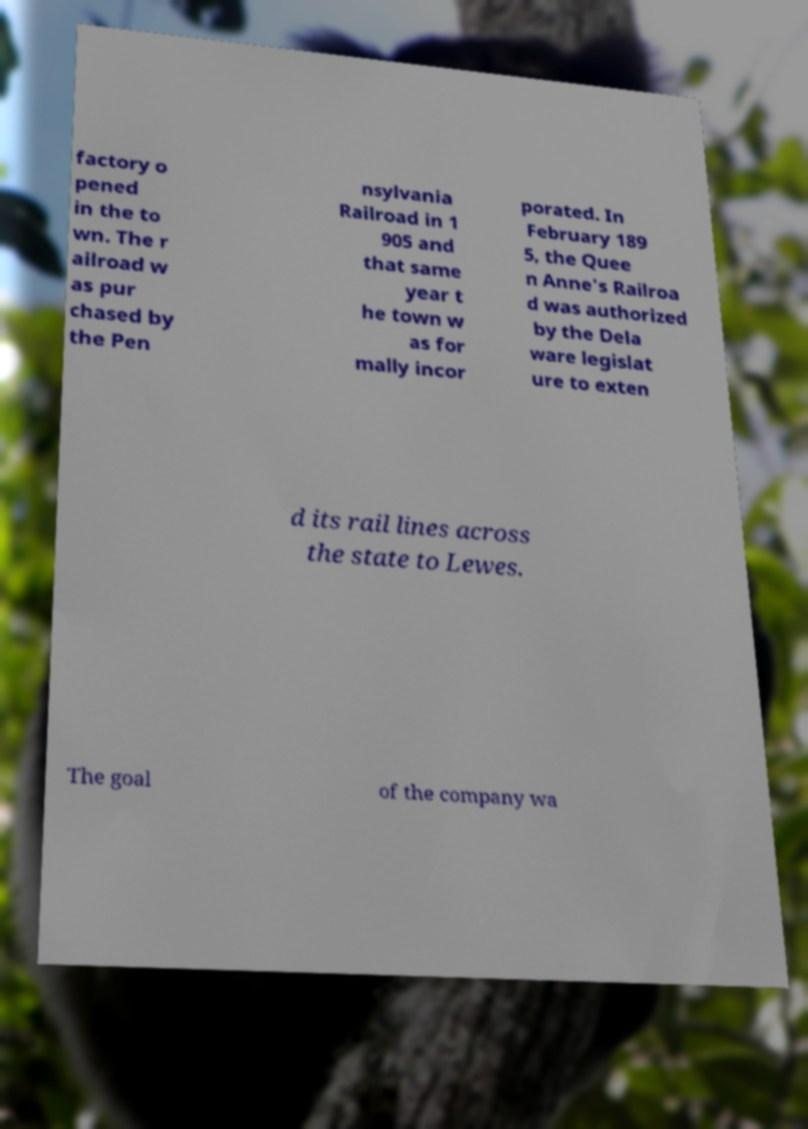Could you assist in decoding the text presented in this image and type it out clearly? factory o pened in the to wn. The r ailroad w as pur chased by the Pen nsylvania Railroad in 1 905 and that same year t he town w as for mally incor porated. In February 189 5, the Quee n Anne's Railroa d was authorized by the Dela ware legislat ure to exten d its rail lines across the state to Lewes. The goal of the company wa 